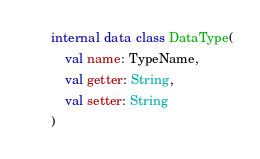<code> <loc_0><loc_0><loc_500><loc_500><_Kotlin_>internal data class DataType(
    val name: TypeName,
    val getter: String,
    val setter: String
)
</code> 